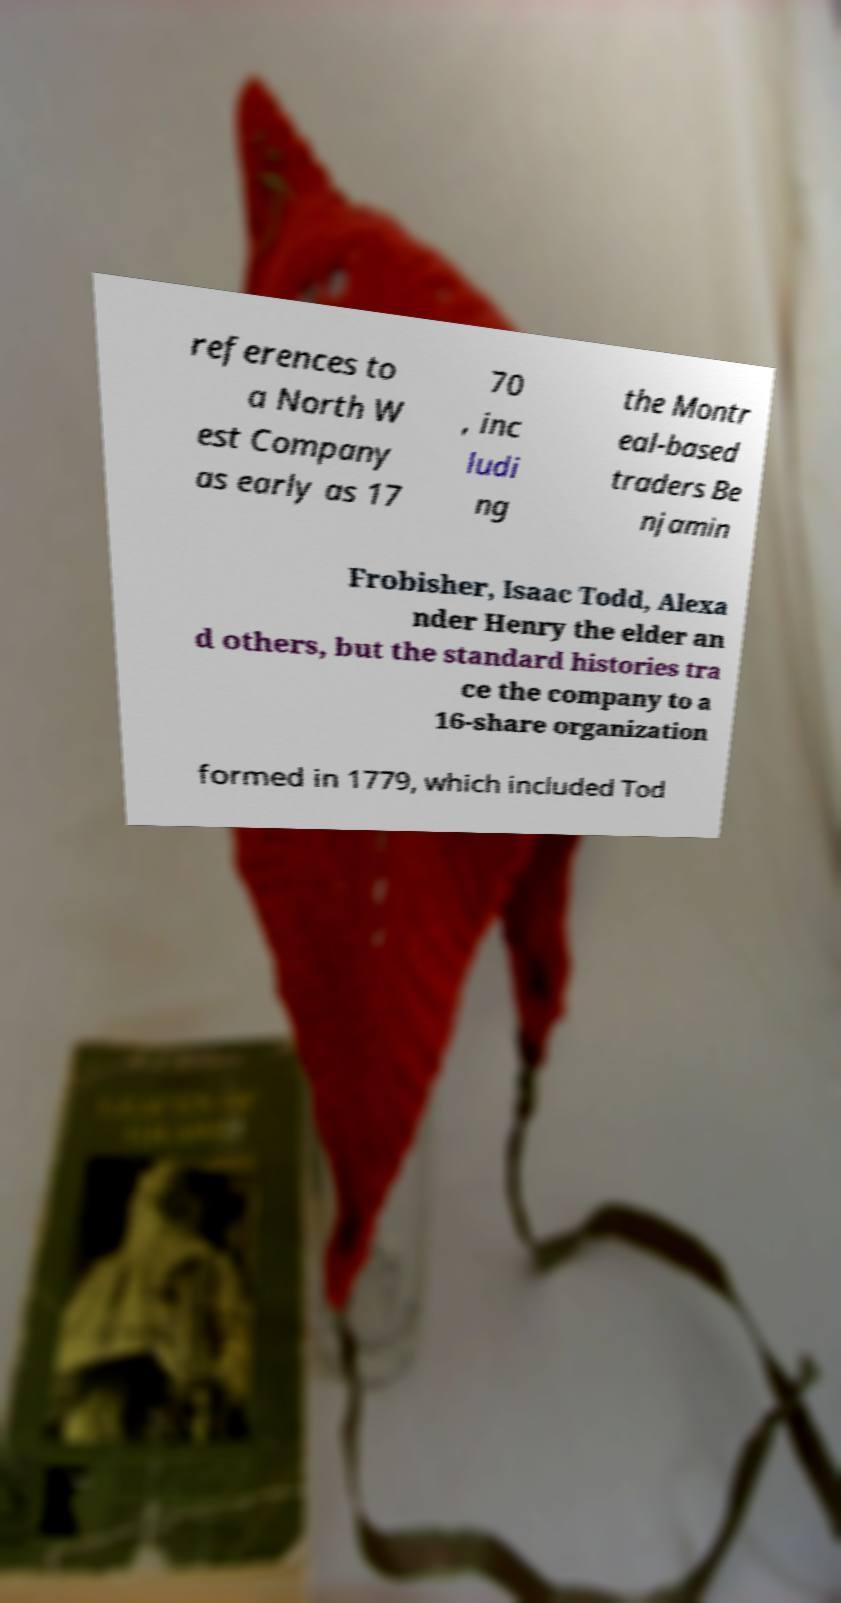There's text embedded in this image that I need extracted. Can you transcribe it verbatim? references to a North W est Company as early as 17 70 , inc ludi ng the Montr eal-based traders Be njamin Frobisher, Isaac Todd, Alexa nder Henry the elder an d others, but the standard histories tra ce the company to a 16-share organization formed in 1779, which included Tod 